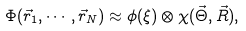<formula> <loc_0><loc_0><loc_500><loc_500>\Phi ( \vec { r } _ { 1 } , \cdots , \vec { r } _ { N } ) \approx \phi ( \xi ) \otimes \chi ( \vec { \Theta } , \vec { R } ) ,</formula> 